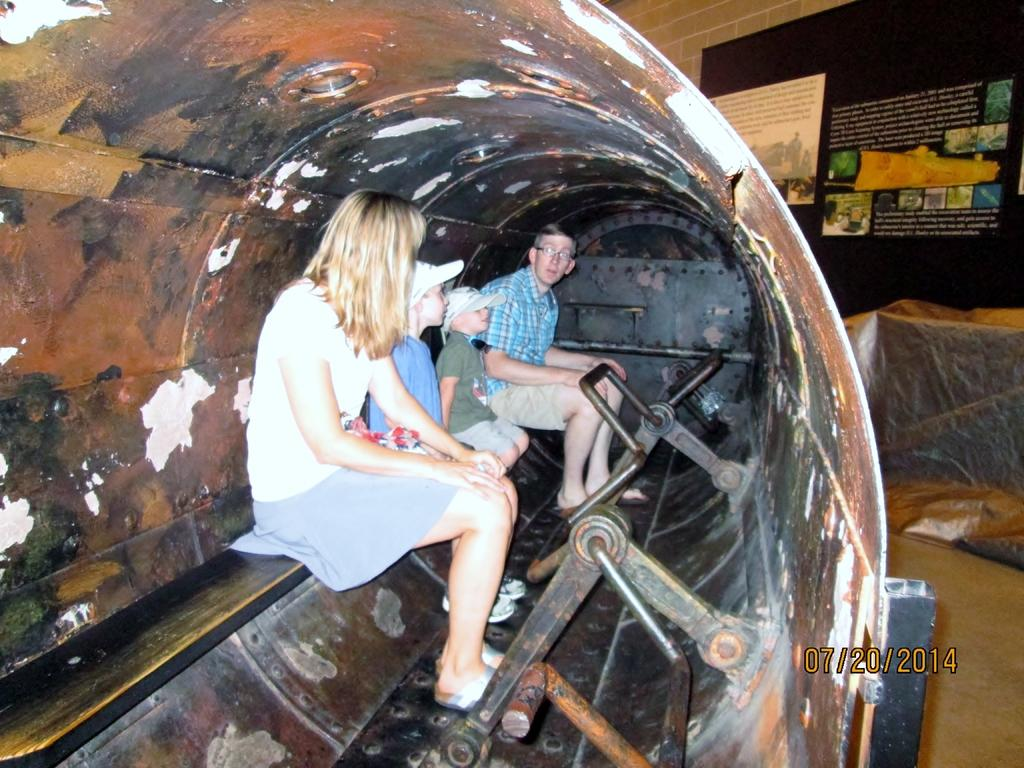What is the main subject of the image? There is an object in the image. How many people are inside the object? Four people are sitting inside the object. What does the object resemble? The object resembles a hole. What is visible behind the object? There is a wall behind the object. What is attached to the wall? A poster is attached to the wall. What type of jewel is being gripped by the people inside the object? There is no jewel present in the image, nor is anyone gripping anything. 